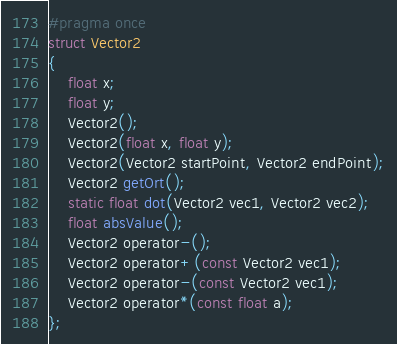<code> <loc_0><loc_0><loc_500><loc_500><_C_>#pragma once
struct Vector2
{
	float x;
	float y;
	Vector2();
	Vector2(float x, float y);
	Vector2(Vector2 startPoint, Vector2 endPoint);
	Vector2 getOrt();
	static float dot(Vector2 vec1, Vector2 vec2);
	float absValue();
	Vector2 operator-();
	Vector2 operator+(const Vector2 vec1);
	Vector2 operator-(const Vector2 vec1);
	Vector2 operator*(const float a);
};

</code> 